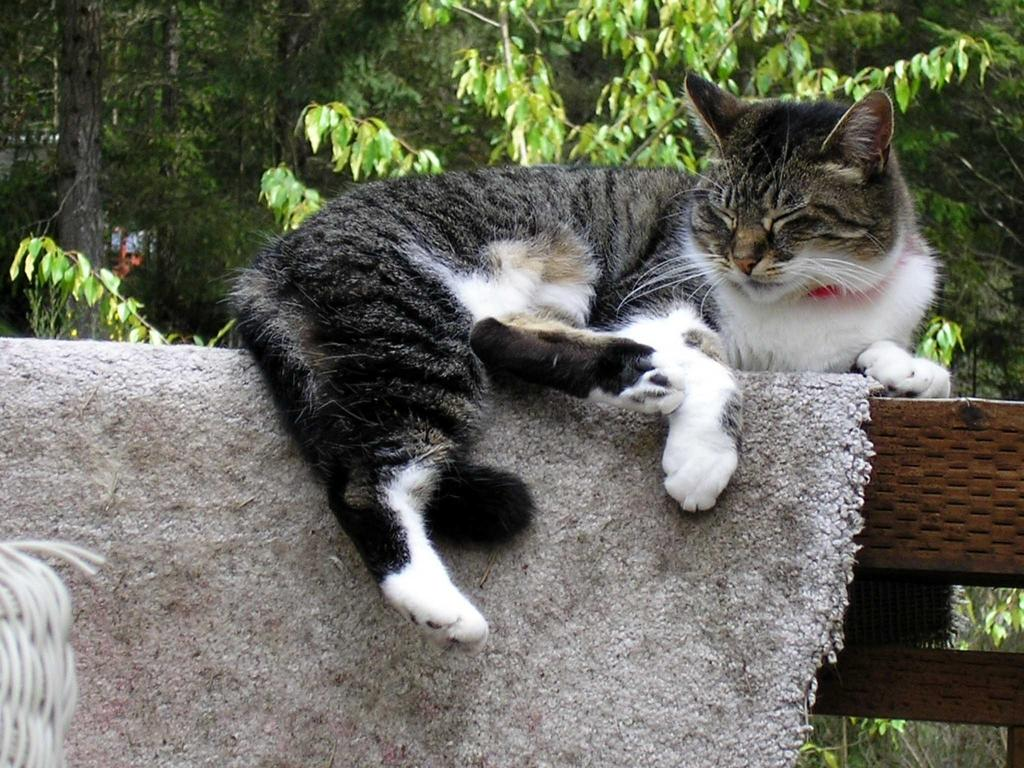What type of animal is in the image? There is a cat in the image. What is the cat doing in the image? The cat is laying down. What is the cat laying on in the image? There is a mat in the image. What can be seen in the background of the image? There are trees in the background of the image. What type of steam is coming from the cat's ears in the image? There is no steam coming from the cat's ears in the image; the cat is simply laying down on a mat. 